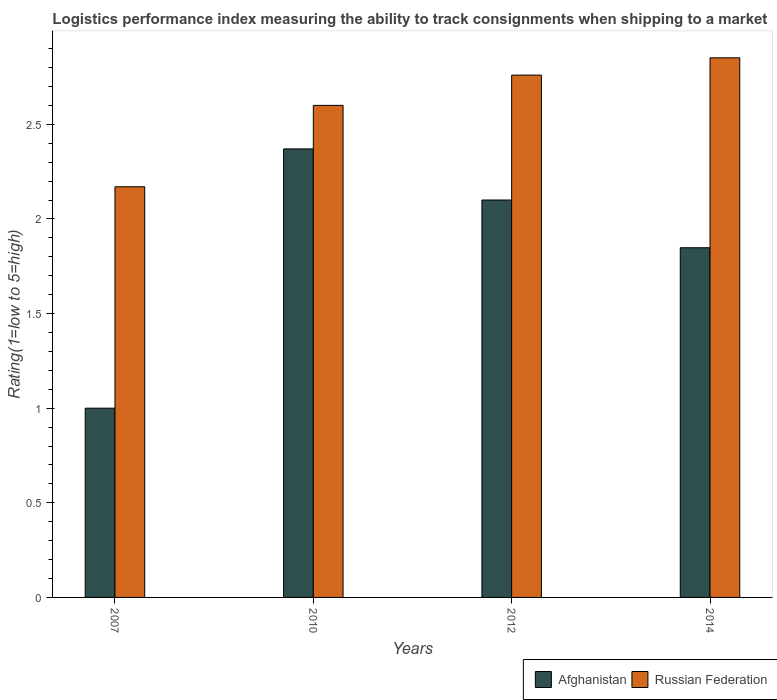How many groups of bars are there?
Give a very brief answer. 4. Are the number of bars per tick equal to the number of legend labels?
Your answer should be very brief. Yes. Are the number of bars on each tick of the X-axis equal?
Your response must be concise. Yes. How many bars are there on the 4th tick from the left?
Provide a succinct answer. 2. How many bars are there on the 4th tick from the right?
Provide a short and direct response. 2. What is the label of the 1st group of bars from the left?
Offer a very short reply. 2007. What is the Logistic performance index in Afghanistan in 2007?
Offer a terse response. 1. Across all years, what is the maximum Logistic performance index in Russian Federation?
Provide a short and direct response. 2.85. Across all years, what is the minimum Logistic performance index in Afghanistan?
Your answer should be compact. 1. In which year was the Logistic performance index in Russian Federation maximum?
Your answer should be very brief. 2014. What is the total Logistic performance index in Russian Federation in the graph?
Give a very brief answer. 10.38. What is the difference between the Logistic performance index in Russian Federation in 2010 and that in 2014?
Offer a very short reply. -0.25. What is the difference between the Logistic performance index in Afghanistan in 2007 and the Logistic performance index in Russian Federation in 2012?
Provide a succinct answer. -1.76. What is the average Logistic performance index in Afghanistan per year?
Offer a very short reply. 1.83. In the year 2012, what is the difference between the Logistic performance index in Russian Federation and Logistic performance index in Afghanistan?
Offer a terse response. 0.66. In how many years, is the Logistic performance index in Afghanistan greater than 0.2?
Your answer should be very brief. 4. What is the ratio of the Logistic performance index in Russian Federation in 2007 to that in 2014?
Provide a short and direct response. 0.76. Is the Logistic performance index in Afghanistan in 2007 less than that in 2012?
Your answer should be compact. Yes. Is the difference between the Logistic performance index in Russian Federation in 2007 and 2014 greater than the difference between the Logistic performance index in Afghanistan in 2007 and 2014?
Keep it short and to the point. Yes. What is the difference between the highest and the second highest Logistic performance index in Russian Federation?
Keep it short and to the point. 0.09. What is the difference between the highest and the lowest Logistic performance index in Afghanistan?
Your answer should be very brief. 1.37. Is the sum of the Logistic performance index in Russian Federation in 2012 and 2014 greater than the maximum Logistic performance index in Afghanistan across all years?
Offer a very short reply. Yes. What does the 1st bar from the left in 2007 represents?
Ensure brevity in your answer.  Afghanistan. What does the 1st bar from the right in 2010 represents?
Keep it short and to the point. Russian Federation. Does the graph contain any zero values?
Give a very brief answer. No. How many legend labels are there?
Your answer should be very brief. 2. How are the legend labels stacked?
Ensure brevity in your answer.  Horizontal. What is the title of the graph?
Provide a succinct answer. Logistics performance index measuring the ability to track consignments when shipping to a market. What is the label or title of the Y-axis?
Offer a very short reply. Rating(1=low to 5=high). What is the Rating(1=low to 5=high) in Afghanistan in 2007?
Ensure brevity in your answer.  1. What is the Rating(1=low to 5=high) in Russian Federation in 2007?
Your response must be concise. 2.17. What is the Rating(1=low to 5=high) of Afghanistan in 2010?
Make the answer very short. 2.37. What is the Rating(1=low to 5=high) of Russian Federation in 2012?
Your answer should be compact. 2.76. What is the Rating(1=low to 5=high) of Afghanistan in 2014?
Your answer should be compact. 1.85. What is the Rating(1=low to 5=high) in Russian Federation in 2014?
Offer a terse response. 2.85. Across all years, what is the maximum Rating(1=low to 5=high) of Afghanistan?
Provide a short and direct response. 2.37. Across all years, what is the maximum Rating(1=low to 5=high) of Russian Federation?
Provide a succinct answer. 2.85. Across all years, what is the minimum Rating(1=low to 5=high) in Afghanistan?
Keep it short and to the point. 1. Across all years, what is the minimum Rating(1=low to 5=high) of Russian Federation?
Give a very brief answer. 2.17. What is the total Rating(1=low to 5=high) in Afghanistan in the graph?
Your response must be concise. 7.32. What is the total Rating(1=low to 5=high) of Russian Federation in the graph?
Give a very brief answer. 10.38. What is the difference between the Rating(1=low to 5=high) of Afghanistan in 2007 and that in 2010?
Your answer should be very brief. -1.37. What is the difference between the Rating(1=low to 5=high) in Russian Federation in 2007 and that in 2010?
Make the answer very short. -0.43. What is the difference between the Rating(1=low to 5=high) of Afghanistan in 2007 and that in 2012?
Offer a terse response. -1.1. What is the difference between the Rating(1=low to 5=high) in Russian Federation in 2007 and that in 2012?
Provide a short and direct response. -0.59. What is the difference between the Rating(1=low to 5=high) in Afghanistan in 2007 and that in 2014?
Keep it short and to the point. -0.85. What is the difference between the Rating(1=low to 5=high) of Russian Federation in 2007 and that in 2014?
Your answer should be very brief. -0.68. What is the difference between the Rating(1=low to 5=high) of Afghanistan in 2010 and that in 2012?
Offer a very short reply. 0.27. What is the difference between the Rating(1=low to 5=high) of Russian Federation in 2010 and that in 2012?
Ensure brevity in your answer.  -0.16. What is the difference between the Rating(1=low to 5=high) in Afghanistan in 2010 and that in 2014?
Your answer should be compact. 0.52. What is the difference between the Rating(1=low to 5=high) of Russian Federation in 2010 and that in 2014?
Offer a terse response. -0.25. What is the difference between the Rating(1=low to 5=high) of Afghanistan in 2012 and that in 2014?
Provide a short and direct response. 0.25. What is the difference between the Rating(1=low to 5=high) in Russian Federation in 2012 and that in 2014?
Make the answer very short. -0.09. What is the difference between the Rating(1=low to 5=high) of Afghanistan in 2007 and the Rating(1=low to 5=high) of Russian Federation in 2010?
Provide a succinct answer. -1.6. What is the difference between the Rating(1=low to 5=high) in Afghanistan in 2007 and the Rating(1=low to 5=high) in Russian Federation in 2012?
Your response must be concise. -1.76. What is the difference between the Rating(1=low to 5=high) in Afghanistan in 2007 and the Rating(1=low to 5=high) in Russian Federation in 2014?
Your response must be concise. -1.85. What is the difference between the Rating(1=low to 5=high) in Afghanistan in 2010 and the Rating(1=low to 5=high) in Russian Federation in 2012?
Ensure brevity in your answer.  -0.39. What is the difference between the Rating(1=low to 5=high) in Afghanistan in 2010 and the Rating(1=low to 5=high) in Russian Federation in 2014?
Offer a very short reply. -0.48. What is the difference between the Rating(1=low to 5=high) in Afghanistan in 2012 and the Rating(1=low to 5=high) in Russian Federation in 2014?
Make the answer very short. -0.75. What is the average Rating(1=low to 5=high) of Afghanistan per year?
Your answer should be compact. 1.83. What is the average Rating(1=low to 5=high) of Russian Federation per year?
Your answer should be very brief. 2.6. In the year 2007, what is the difference between the Rating(1=low to 5=high) in Afghanistan and Rating(1=low to 5=high) in Russian Federation?
Provide a short and direct response. -1.17. In the year 2010, what is the difference between the Rating(1=low to 5=high) in Afghanistan and Rating(1=low to 5=high) in Russian Federation?
Give a very brief answer. -0.23. In the year 2012, what is the difference between the Rating(1=low to 5=high) of Afghanistan and Rating(1=low to 5=high) of Russian Federation?
Make the answer very short. -0.66. In the year 2014, what is the difference between the Rating(1=low to 5=high) of Afghanistan and Rating(1=low to 5=high) of Russian Federation?
Your response must be concise. -1. What is the ratio of the Rating(1=low to 5=high) in Afghanistan in 2007 to that in 2010?
Offer a very short reply. 0.42. What is the ratio of the Rating(1=low to 5=high) of Russian Federation in 2007 to that in 2010?
Your answer should be compact. 0.83. What is the ratio of the Rating(1=low to 5=high) in Afghanistan in 2007 to that in 2012?
Your answer should be very brief. 0.48. What is the ratio of the Rating(1=low to 5=high) of Russian Federation in 2007 to that in 2012?
Offer a terse response. 0.79. What is the ratio of the Rating(1=low to 5=high) of Afghanistan in 2007 to that in 2014?
Provide a short and direct response. 0.54. What is the ratio of the Rating(1=low to 5=high) of Russian Federation in 2007 to that in 2014?
Ensure brevity in your answer.  0.76. What is the ratio of the Rating(1=low to 5=high) of Afghanistan in 2010 to that in 2012?
Keep it short and to the point. 1.13. What is the ratio of the Rating(1=low to 5=high) of Russian Federation in 2010 to that in 2012?
Provide a short and direct response. 0.94. What is the ratio of the Rating(1=low to 5=high) of Afghanistan in 2010 to that in 2014?
Keep it short and to the point. 1.28. What is the ratio of the Rating(1=low to 5=high) in Russian Federation in 2010 to that in 2014?
Offer a very short reply. 0.91. What is the ratio of the Rating(1=low to 5=high) in Afghanistan in 2012 to that in 2014?
Ensure brevity in your answer.  1.14. What is the ratio of the Rating(1=low to 5=high) in Russian Federation in 2012 to that in 2014?
Make the answer very short. 0.97. What is the difference between the highest and the second highest Rating(1=low to 5=high) of Afghanistan?
Offer a very short reply. 0.27. What is the difference between the highest and the second highest Rating(1=low to 5=high) in Russian Federation?
Provide a succinct answer. 0.09. What is the difference between the highest and the lowest Rating(1=low to 5=high) in Afghanistan?
Make the answer very short. 1.37. What is the difference between the highest and the lowest Rating(1=low to 5=high) in Russian Federation?
Keep it short and to the point. 0.68. 